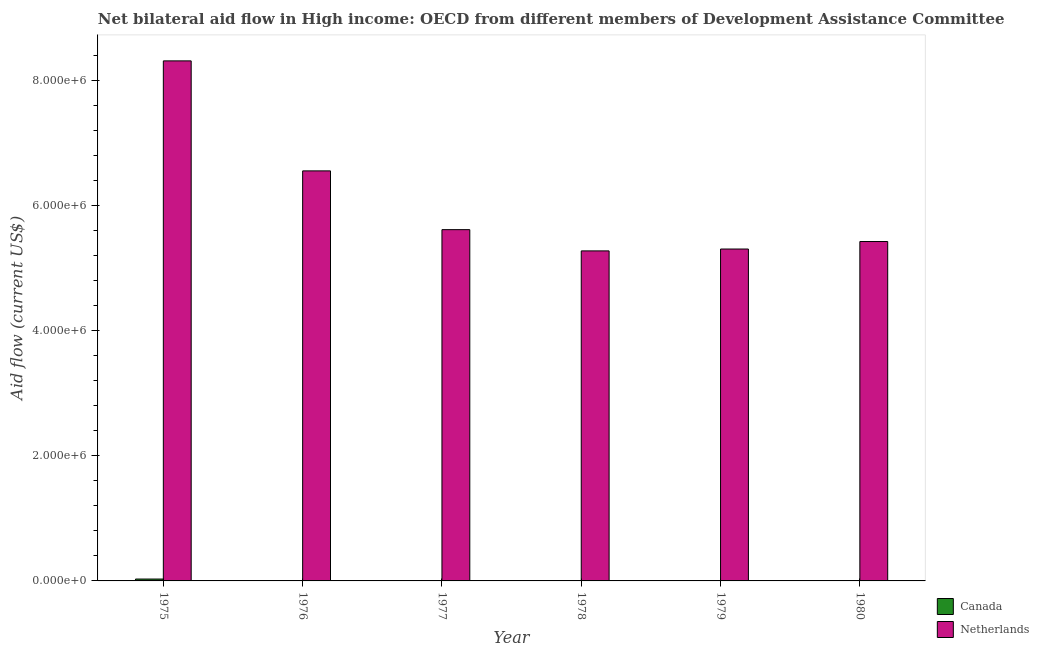Are the number of bars per tick equal to the number of legend labels?
Your answer should be compact. No. How many bars are there on the 3rd tick from the left?
Give a very brief answer. 1. How many bars are there on the 5th tick from the right?
Keep it short and to the point. 1. What is the label of the 1st group of bars from the left?
Your response must be concise. 1975. In how many cases, is the number of bars for a given year not equal to the number of legend labels?
Offer a very short reply. 5. What is the amount of aid given by netherlands in 1975?
Provide a short and direct response. 8.32e+06. Across all years, what is the maximum amount of aid given by netherlands?
Offer a terse response. 8.32e+06. Across all years, what is the minimum amount of aid given by netherlands?
Offer a terse response. 5.28e+06. In which year was the amount of aid given by netherlands maximum?
Your answer should be compact. 1975. What is the total amount of aid given by netherlands in the graph?
Ensure brevity in your answer.  3.65e+07. What is the difference between the amount of aid given by netherlands in 1978 and that in 1980?
Provide a succinct answer. -1.50e+05. What is the difference between the amount of aid given by netherlands in 1979 and the amount of aid given by canada in 1980?
Offer a very short reply. -1.20e+05. In the year 1978, what is the difference between the amount of aid given by netherlands and amount of aid given by canada?
Your response must be concise. 0. What is the ratio of the amount of aid given by netherlands in 1975 to that in 1976?
Offer a very short reply. 1.27. Is the amount of aid given by netherlands in 1978 less than that in 1980?
Your answer should be compact. Yes. Is the difference between the amount of aid given by netherlands in 1977 and 1980 greater than the difference between the amount of aid given by canada in 1977 and 1980?
Provide a succinct answer. No. What is the difference between the highest and the lowest amount of aid given by canada?
Give a very brief answer. 3.00e+04. In how many years, is the amount of aid given by canada greater than the average amount of aid given by canada taken over all years?
Your answer should be compact. 1. Where does the legend appear in the graph?
Provide a succinct answer. Bottom right. How many legend labels are there?
Your answer should be very brief. 2. What is the title of the graph?
Ensure brevity in your answer.  Net bilateral aid flow in High income: OECD from different members of Development Assistance Committee. What is the Aid flow (current US$) of Netherlands in 1975?
Your answer should be compact. 8.32e+06. What is the Aid flow (current US$) of Netherlands in 1976?
Make the answer very short. 6.56e+06. What is the Aid flow (current US$) in Canada in 1977?
Offer a terse response. 0. What is the Aid flow (current US$) of Netherlands in 1977?
Your answer should be compact. 5.62e+06. What is the Aid flow (current US$) in Netherlands in 1978?
Your answer should be very brief. 5.28e+06. What is the Aid flow (current US$) in Canada in 1979?
Your answer should be very brief. 0. What is the Aid flow (current US$) in Netherlands in 1979?
Offer a terse response. 5.31e+06. What is the Aid flow (current US$) of Canada in 1980?
Ensure brevity in your answer.  0. What is the Aid flow (current US$) in Netherlands in 1980?
Keep it short and to the point. 5.43e+06. Across all years, what is the maximum Aid flow (current US$) in Canada?
Make the answer very short. 3.00e+04. Across all years, what is the maximum Aid flow (current US$) of Netherlands?
Provide a succinct answer. 8.32e+06. Across all years, what is the minimum Aid flow (current US$) in Netherlands?
Offer a very short reply. 5.28e+06. What is the total Aid flow (current US$) in Canada in the graph?
Your response must be concise. 3.00e+04. What is the total Aid flow (current US$) of Netherlands in the graph?
Make the answer very short. 3.65e+07. What is the difference between the Aid flow (current US$) of Netherlands in 1975 and that in 1976?
Offer a very short reply. 1.76e+06. What is the difference between the Aid flow (current US$) of Netherlands in 1975 and that in 1977?
Make the answer very short. 2.70e+06. What is the difference between the Aid flow (current US$) of Netherlands in 1975 and that in 1978?
Provide a short and direct response. 3.04e+06. What is the difference between the Aid flow (current US$) of Netherlands in 1975 and that in 1979?
Your answer should be compact. 3.01e+06. What is the difference between the Aid flow (current US$) in Netherlands in 1975 and that in 1980?
Your answer should be compact. 2.89e+06. What is the difference between the Aid flow (current US$) in Netherlands in 1976 and that in 1977?
Make the answer very short. 9.40e+05. What is the difference between the Aid flow (current US$) of Netherlands in 1976 and that in 1978?
Provide a succinct answer. 1.28e+06. What is the difference between the Aid flow (current US$) in Netherlands in 1976 and that in 1979?
Your response must be concise. 1.25e+06. What is the difference between the Aid flow (current US$) in Netherlands in 1976 and that in 1980?
Make the answer very short. 1.13e+06. What is the difference between the Aid flow (current US$) in Netherlands in 1977 and that in 1978?
Give a very brief answer. 3.40e+05. What is the difference between the Aid flow (current US$) in Netherlands in 1977 and that in 1979?
Provide a succinct answer. 3.10e+05. What is the difference between the Aid flow (current US$) of Netherlands in 1978 and that in 1979?
Give a very brief answer. -3.00e+04. What is the difference between the Aid flow (current US$) in Canada in 1975 and the Aid flow (current US$) in Netherlands in 1976?
Ensure brevity in your answer.  -6.53e+06. What is the difference between the Aid flow (current US$) of Canada in 1975 and the Aid flow (current US$) of Netherlands in 1977?
Give a very brief answer. -5.59e+06. What is the difference between the Aid flow (current US$) of Canada in 1975 and the Aid flow (current US$) of Netherlands in 1978?
Offer a terse response. -5.25e+06. What is the difference between the Aid flow (current US$) of Canada in 1975 and the Aid flow (current US$) of Netherlands in 1979?
Your response must be concise. -5.28e+06. What is the difference between the Aid flow (current US$) in Canada in 1975 and the Aid flow (current US$) in Netherlands in 1980?
Make the answer very short. -5.40e+06. What is the average Aid flow (current US$) in Canada per year?
Make the answer very short. 5000. What is the average Aid flow (current US$) of Netherlands per year?
Your response must be concise. 6.09e+06. In the year 1975, what is the difference between the Aid flow (current US$) in Canada and Aid flow (current US$) in Netherlands?
Provide a short and direct response. -8.29e+06. What is the ratio of the Aid flow (current US$) in Netherlands in 1975 to that in 1976?
Provide a succinct answer. 1.27. What is the ratio of the Aid flow (current US$) in Netherlands in 1975 to that in 1977?
Give a very brief answer. 1.48. What is the ratio of the Aid flow (current US$) of Netherlands in 1975 to that in 1978?
Ensure brevity in your answer.  1.58. What is the ratio of the Aid flow (current US$) in Netherlands in 1975 to that in 1979?
Your answer should be compact. 1.57. What is the ratio of the Aid flow (current US$) in Netherlands in 1975 to that in 1980?
Provide a succinct answer. 1.53. What is the ratio of the Aid flow (current US$) of Netherlands in 1976 to that in 1977?
Your answer should be very brief. 1.17. What is the ratio of the Aid flow (current US$) in Netherlands in 1976 to that in 1978?
Ensure brevity in your answer.  1.24. What is the ratio of the Aid flow (current US$) of Netherlands in 1976 to that in 1979?
Your answer should be compact. 1.24. What is the ratio of the Aid flow (current US$) in Netherlands in 1976 to that in 1980?
Give a very brief answer. 1.21. What is the ratio of the Aid flow (current US$) in Netherlands in 1977 to that in 1978?
Offer a terse response. 1.06. What is the ratio of the Aid flow (current US$) of Netherlands in 1977 to that in 1979?
Keep it short and to the point. 1.06. What is the ratio of the Aid flow (current US$) in Netherlands in 1977 to that in 1980?
Ensure brevity in your answer.  1.03. What is the ratio of the Aid flow (current US$) in Netherlands in 1978 to that in 1980?
Give a very brief answer. 0.97. What is the ratio of the Aid flow (current US$) of Netherlands in 1979 to that in 1980?
Offer a terse response. 0.98. What is the difference between the highest and the second highest Aid flow (current US$) of Netherlands?
Give a very brief answer. 1.76e+06. What is the difference between the highest and the lowest Aid flow (current US$) of Canada?
Offer a very short reply. 3.00e+04. What is the difference between the highest and the lowest Aid flow (current US$) of Netherlands?
Keep it short and to the point. 3.04e+06. 